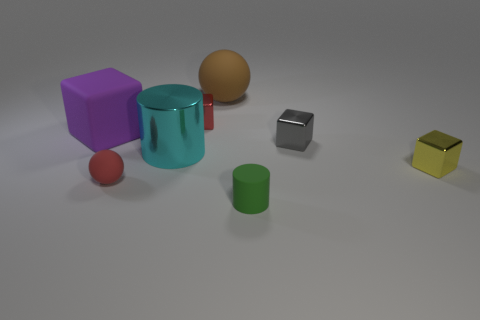Subtract 1 cubes. How many cubes are left? 3 Subtract all brown blocks. Subtract all green cylinders. How many blocks are left? 4 Add 2 red metallic cubes. How many objects exist? 10 Subtract all balls. How many objects are left? 6 Subtract 1 gray cubes. How many objects are left? 7 Subtract all small yellow metal objects. Subtract all big matte spheres. How many objects are left? 6 Add 5 big brown matte objects. How many big brown matte objects are left? 6 Add 5 large blue matte cubes. How many large blue matte cubes exist? 5 